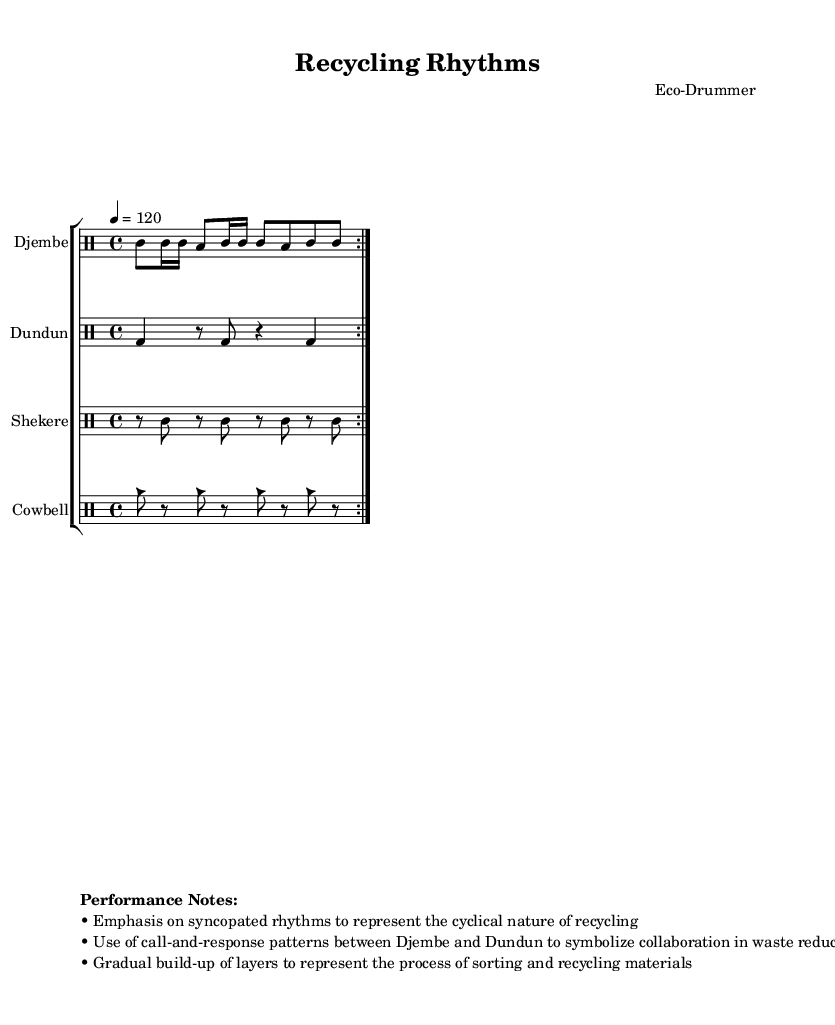What is the key signature of this music? The key signature is C major, which has no sharps or flats indicated at the beginning of the staff.
Answer: C major What is the time signature of this music? The time signature is shown as 4/4, meaning there are four beats per measure and the quarter note gets one beat.
Answer: 4/4 What is the tempo marking given for this piece? The tempo marking indicates '4 = 120', meaning the piece should be played at 120 beats per minute, with four quarter notes counted each measure.
Answer: 120 Which instruments are featured in this composition? The instruments in the composition are Djembe, Dundun, Shekere, and Cowbell, all specified in the staff groups.
Answer: Djembe, Dundun, Shekere, Cowbell Explain the significance of the call-and-response pattern between Djembe and Dundun based on the performance notes. The call-and-response pattern symbolizes the collaboration needed for waste reduction efforts, enhancing communication through rhythmic exchange between the two instruments.
Answer: Collaboration How does the rhythmic layering technique represent the process of recycling? The gradual build-up of layers in the rhythm represents the sorting and recycling process, where different materials are combined at various stages, creating complexity over time similar to the recycling process.
Answer: Sorting and recycling 